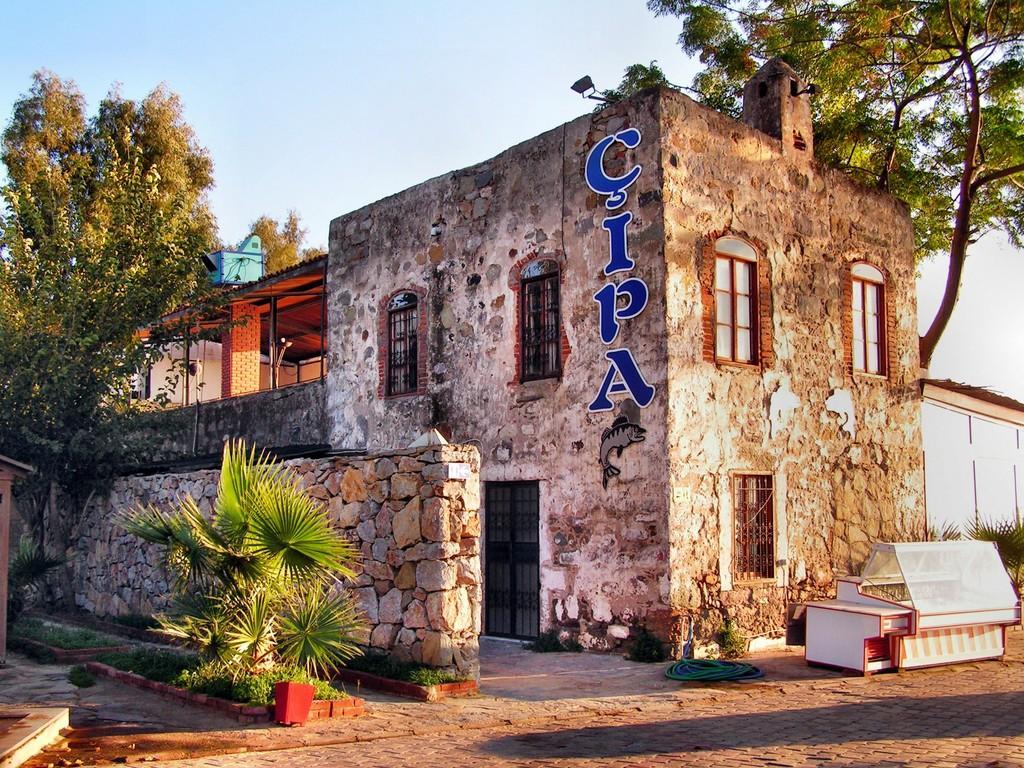Can you describe this image briefly? In this picture I can see the path in front and I see few plants. In the middle of this picture I see few trees and few buildings and I see the wall. In the background I see the sky. I can also see that there is something written on the building which is in front and I see the depiction of a fish on the wall. 